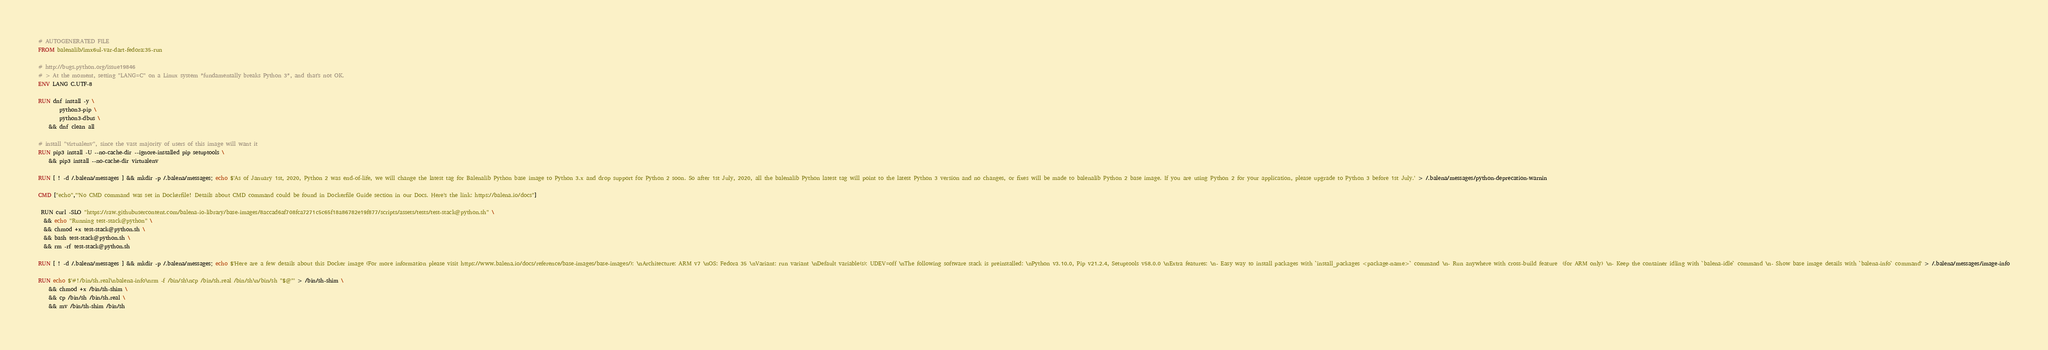Convert code to text. <code><loc_0><loc_0><loc_500><loc_500><_Dockerfile_># AUTOGENERATED FILE
FROM balenalib/imx6ul-var-dart-fedora:35-run

# http://bugs.python.org/issue19846
# > At the moment, setting "LANG=C" on a Linux system *fundamentally breaks Python 3*, and that's not OK.
ENV LANG C.UTF-8

RUN dnf install -y \
		python3-pip \
		python3-dbus \
	&& dnf clean all

# install "virtualenv", since the vast majority of users of this image will want it
RUN pip3 install -U --no-cache-dir --ignore-installed pip setuptools \
	&& pip3 install --no-cache-dir virtualenv

RUN [ ! -d /.balena/messages ] && mkdir -p /.balena/messages; echo $'As of January 1st, 2020, Python 2 was end-of-life, we will change the latest tag for Balenalib Python base image to Python 3.x and drop support for Python 2 soon. So after 1st July, 2020, all the balenalib Python latest tag will point to the latest Python 3 version and no changes, or fixes will be made to balenalib Python 2 base image. If you are using Python 2 for your application, please upgrade to Python 3 before 1st July.' > /.balena/messages/python-deprecation-warnin

CMD ["echo","'No CMD command was set in Dockerfile! Details about CMD command could be found in Dockerfile Guide section in our Docs. Here's the link: https://balena.io/docs"]

 RUN curl -SLO "https://raw.githubusercontent.com/balena-io-library/base-images/8accad6af708fca7271c5c65f18a86782e19f877/scripts/assets/tests/test-stack@python.sh" \
  && echo "Running test-stack@python" \
  && chmod +x test-stack@python.sh \
  && bash test-stack@python.sh \
  && rm -rf test-stack@python.sh 

RUN [ ! -d /.balena/messages ] && mkdir -p /.balena/messages; echo $'Here are a few details about this Docker image (For more information please visit https://www.balena.io/docs/reference/base-images/base-images/): \nArchitecture: ARM v7 \nOS: Fedora 35 \nVariant: run variant \nDefault variable(s): UDEV=off \nThe following software stack is preinstalled: \nPython v3.10.0, Pip v21.2.4, Setuptools v58.0.0 \nExtra features: \n- Easy way to install packages with `install_packages <package-name>` command \n- Run anywhere with cross-build feature  (for ARM only) \n- Keep the container idling with `balena-idle` command \n- Show base image details with `balena-info` command' > /.balena/messages/image-info

RUN echo $'#!/bin/sh.real\nbalena-info\nrm -f /bin/sh\ncp /bin/sh.real /bin/sh\n/bin/sh "$@"' > /bin/sh-shim \
	&& chmod +x /bin/sh-shim \
	&& cp /bin/sh /bin/sh.real \
	&& mv /bin/sh-shim /bin/sh</code> 